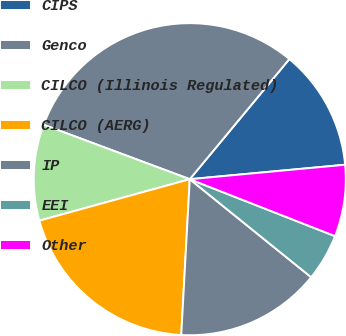Convert chart. <chart><loc_0><loc_0><loc_500><loc_500><pie_chart><fcel>CIPS<fcel>Genco<fcel>CILCO (Illinois Regulated)<fcel>CILCO (AERG)<fcel>IP<fcel>EEI<fcel>Other<nl><fcel>12.51%<fcel>30.34%<fcel>9.96%<fcel>19.85%<fcel>15.06%<fcel>4.87%<fcel>7.42%<nl></chart> 